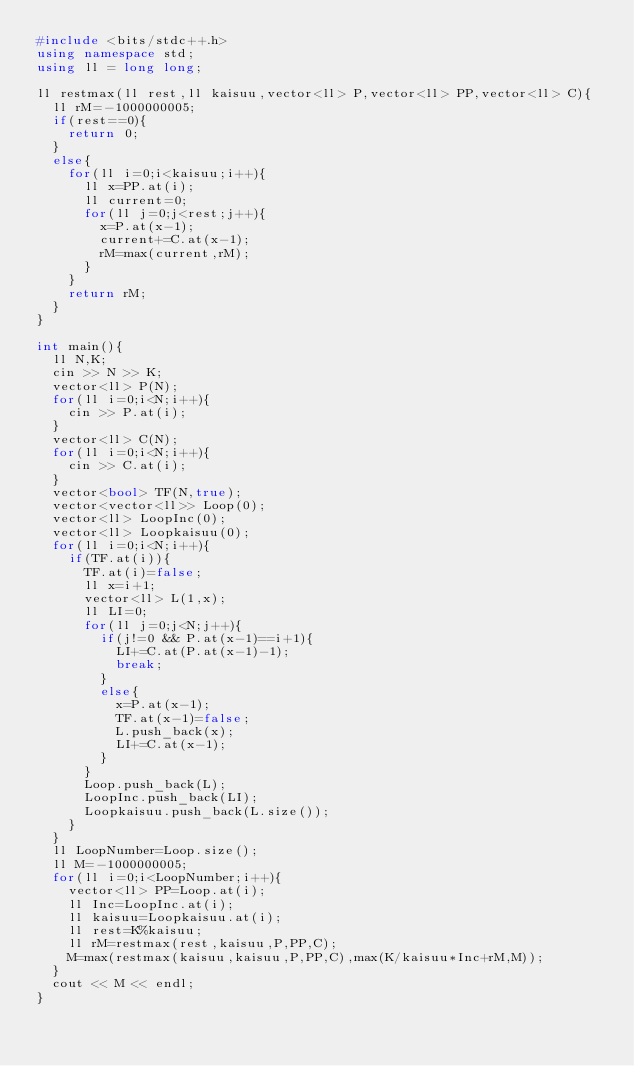Convert code to text. <code><loc_0><loc_0><loc_500><loc_500><_C++_>#include <bits/stdc++.h>
using namespace std;
using ll = long long;

ll restmax(ll rest,ll kaisuu,vector<ll> P,vector<ll> PP,vector<ll> C){
  ll rM=-1000000005;
  if(rest==0){
    return 0;
  }
  else{
    for(ll i=0;i<kaisuu;i++){
      ll x=PP.at(i);
      ll current=0;
      for(ll j=0;j<rest;j++){
        x=P.at(x-1);
        current+=C.at(x-1);
        rM=max(current,rM);
      }
    }
    return rM;
  }
}

int main(){
  ll N,K;
  cin >> N >> K;
  vector<ll> P(N);
  for(ll i=0;i<N;i++){
    cin >> P.at(i);
  }
  vector<ll> C(N);
  for(ll i=0;i<N;i++){
    cin >> C.at(i);
  }
  vector<bool> TF(N,true);
  vector<vector<ll>> Loop(0);
  vector<ll> LoopInc(0);
  vector<ll> Loopkaisuu(0);
  for(ll i=0;i<N;i++){
    if(TF.at(i)){
      TF.at(i)=false;
      ll x=i+1;
      vector<ll> L(1,x);
      ll LI=0;
      for(ll j=0;j<N;j++){
        if(j!=0 && P.at(x-1)==i+1){
          LI+=C.at(P.at(x-1)-1);
          break;
        }
        else{
          x=P.at(x-1);
          TF.at(x-1)=false;
          L.push_back(x);
          LI+=C.at(x-1);
        }
      }
      Loop.push_back(L);
      LoopInc.push_back(LI);
      Loopkaisuu.push_back(L.size());
    }
  }
  ll LoopNumber=Loop.size();
  ll M=-1000000005;
  for(ll i=0;i<LoopNumber;i++){
    vector<ll> PP=Loop.at(i);
    ll Inc=LoopInc.at(i);
    ll kaisuu=Loopkaisuu.at(i);
    ll rest=K%kaisuu;
    ll rM=restmax(rest,kaisuu,P,PP,C); 
    M=max(restmax(kaisuu,kaisuu,P,PP,C),max(K/kaisuu*Inc+rM,M));
  }
  cout << M << endl;
}
</code> 